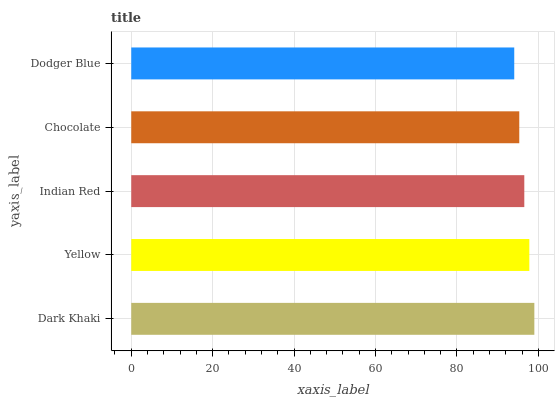Is Dodger Blue the minimum?
Answer yes or no. Yes. Is Dark Khaki the maximum?
Answer yes or no. Yes. Is Yellow the minimum?
Answer yes or no. No. Is Yellow the maximum?
Answer yes or no. No. Is Dark Khaki greater than Yellow?
Answer yes or no. Yes. Is Yellow less than Dark Khaki?
Answer yes or no. Yes. Is Yellow greater than Dark Khaki?
Answer yes or no. No. Is Dark Khaki less than Yellow?
Answer yes or no. No. Is Indian Red the high median?
Answer yes or no. Yes. Is Indian Red the low median?
Answer yes or no. Yes. Is Chocolate the high median?
Answer yes or no. No. Is Dark Khaki the low median?
Answer yes or no. No. 